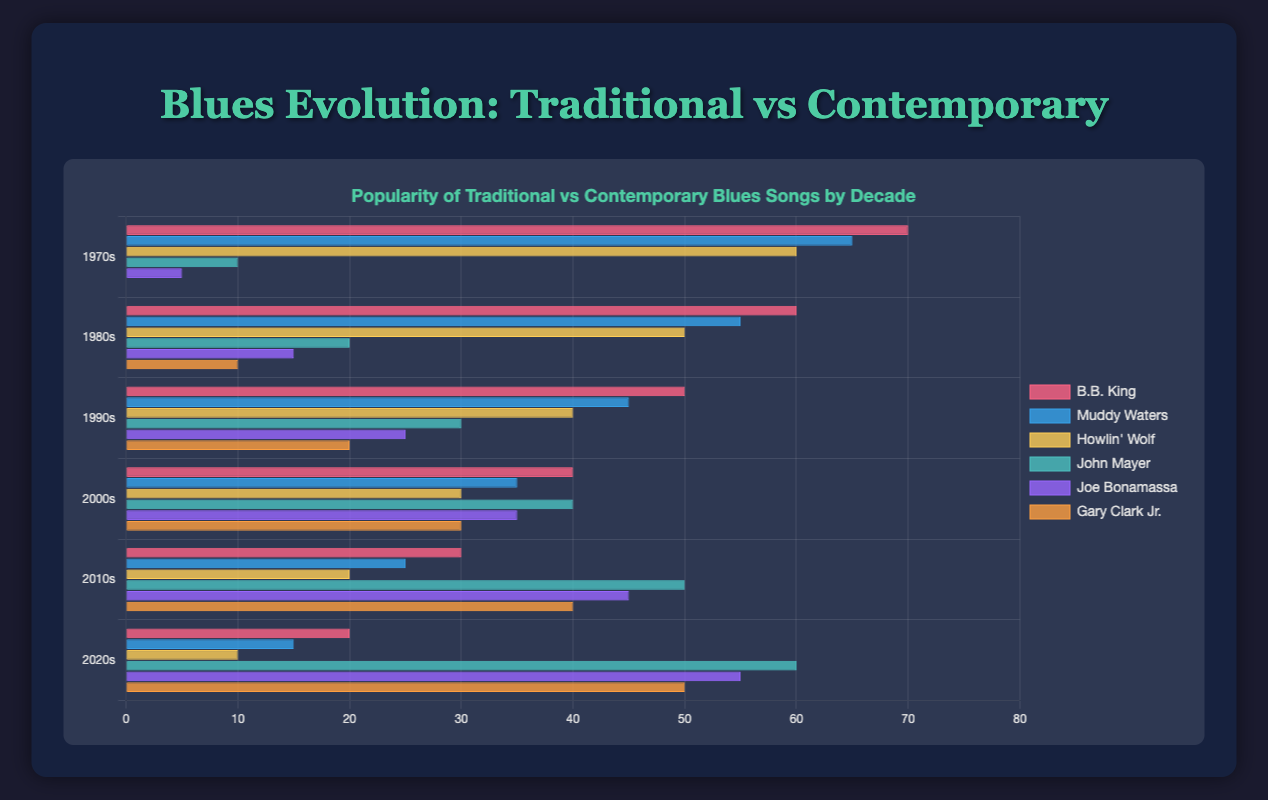Which traditional blues artist had the highest popularity in the 1970s? The highest value for the 1970s among traditional blues artists is 70 (B.B. King), followed by 65 (Muddy Waters) and 60 (Howlin' Wolf).
Answer: B.B. King How did the popularity of John Mayer's music change from the 1970s to the 2020s? In the 1970s, John Mayer had a popularity of 10. By the 2020s, this increased to 60. This indicates a steady increase each decade.
Answer: Increased Which contemporary blues artist showed the greatest increase in popularity from the 1970s to the 2020s? From the 1970s to the 2020s: John Mayer increased by 50 (10 to 60), Joe Bonamassa increased by 50 (5 to 55), and Gary Clark Jr. increased by 50 (0 to 50). All showed the same increase.
Answer: All Who had a higher popularity in the 2000s: Muddy Waters or Joe Bonamassa? Muddy Waters had a popularity of 35 in the 2000s and Joe Bonamassa had 35 as well. They were equal.
Answer: Equal What is the average popularity of traditional blues artists in the 1990s? Adding popularity values for the 1990s: B.B. King (50), Muddy Waters (45), Howlin' Wolf (40). Sum = 135. Average = 135/3.
Answer: 45 Which decade saw the highest popularity for contemporary blues as a genre compared to traditional blues? By comparing each decade, in the 2020s, the sum of contemporary blues values (60+55+50=165) is higher than traditional blues values (20+15+10=45).
Answer: 2020s Compare the popularity trend of B.B. King and John Mayer from the 1970s to the 2020s. B.B. King's popularity decreased from 70 to 20, while John Mayer's increased from 10 to 60.
Answer: Opposite trends Which artist had the most consistent popularity over the decades? By examining the changes in popularity values: Joe Bonamassa shows a consistent increase without major fluctuations each decade.
Answer: Joe Bonamassa 